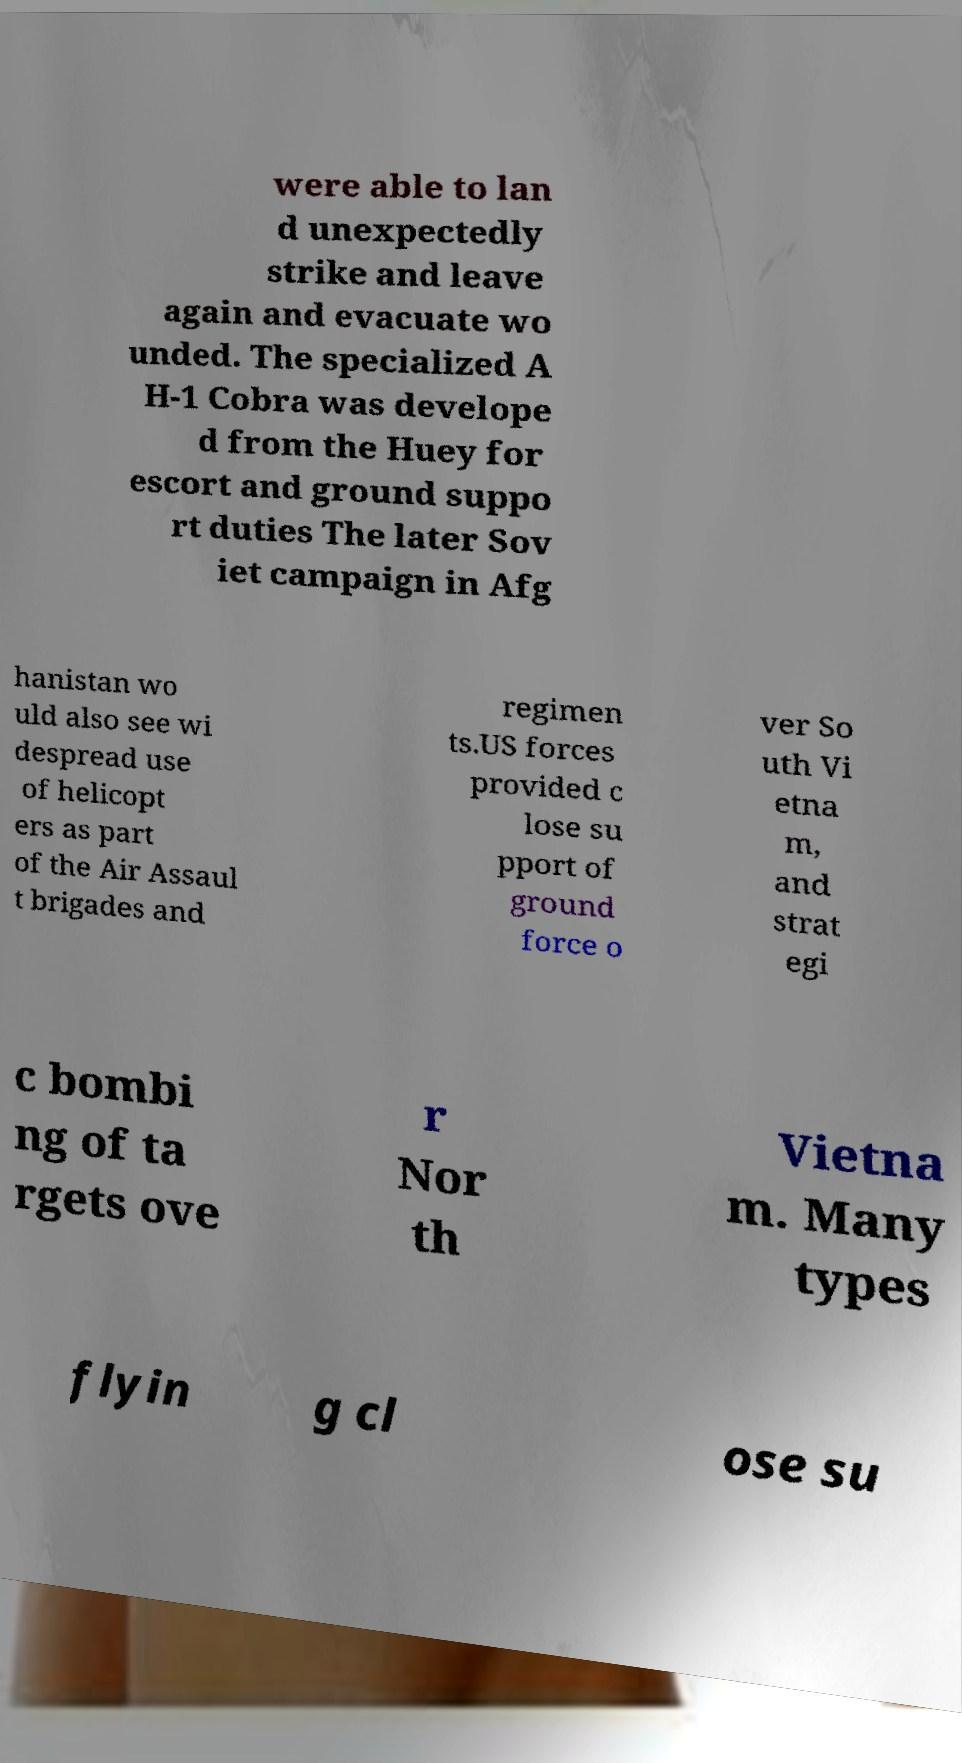I need the written content from this picture converted into text. Can you do that? were able to lan d unexpectedly strike and leave again and evacuate wo unded. The specialized A H-1 Cobra was develope d from the Huey for escort and ground suppo rt duties The later Sov iet campaign in Afg hanistan wo uld also see wi despread use of helicopt ers as part of the Air Assaul t brigades and regimen ts.US forces provided c lose su pport of ground force o ver So uth Vi etna m, and strat egi c bombi ng of ta rgets ove r Nor th Vietna m. Many types flyin g cl ose su 